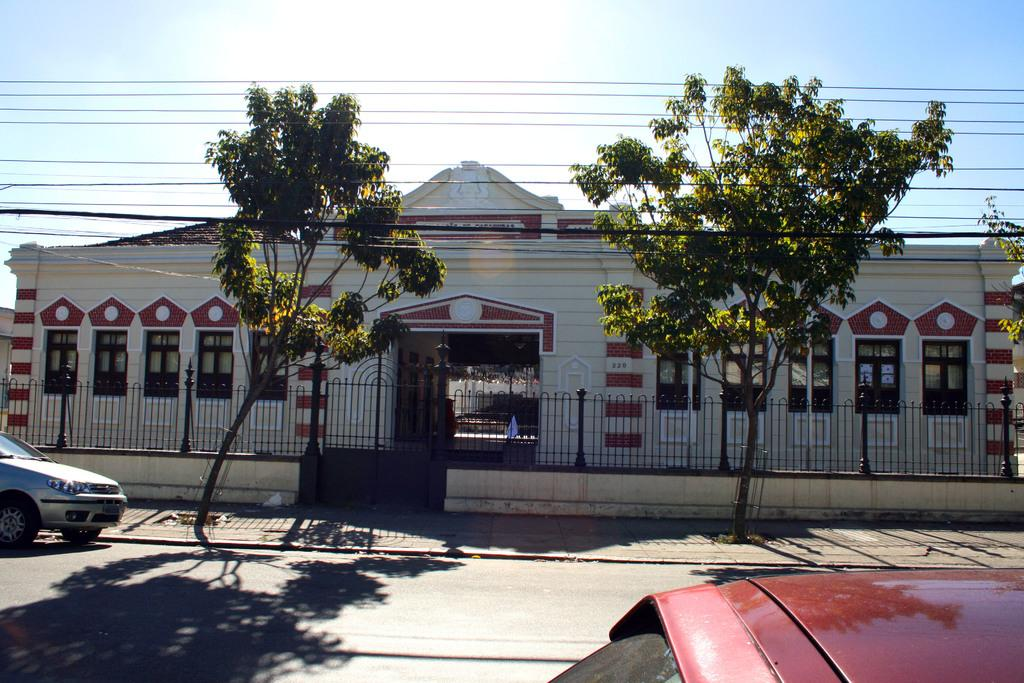What type of structure is present in the image? There is a house in the image. What is surrounding the house? There is fencing in the image. What type of vehicles can be seen in the image? There are cars in the image. What type of vegetation is present in the image? There are trees in the image. What can be seen in the background of the image? The sky is visible in the background of the image. Reasoning: Let' Let's think step by step in order to produce the conversation. We start by identifying the main subject in the image, which is the house. Then, we expand the conversation to include other items that are also visible, such as fencing, cars, trees, and the sky. Each question is designed to elicit a specific detail about the image that is known from the provided facts. Absurd Question/Answer: How does the maid clean the house in the image? There is no maid present in the image, so it is not possible to determine how a maid might clean the house in the image? What time of day is depicted in the image? The provided facts do not mention the time of day, so it is not possible to determine the time of day from the image. 